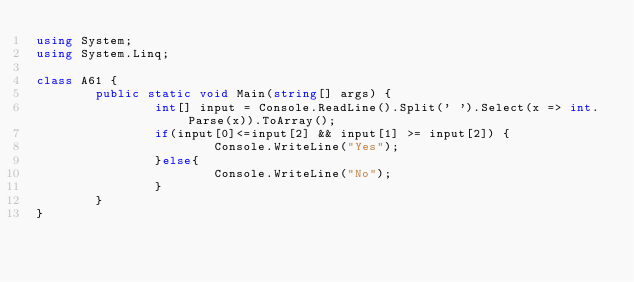Convert code to text. <code><loc_0><loc_0><loc_500><loc_500><_C#_>using System;
using System.Linq;

class A61 {
		public static void Main(string[] args) {
				int[] input = Console.ReadLine().Split(' ').Select(x => int.Parse(x)).ToArray();
				if(input[0]<=input[2] && input[1] >= input[2]) {
						Console.WriteLine("Yes");
				}else{
						Console.WriteLine("No");
				}
		}
}
</code> 